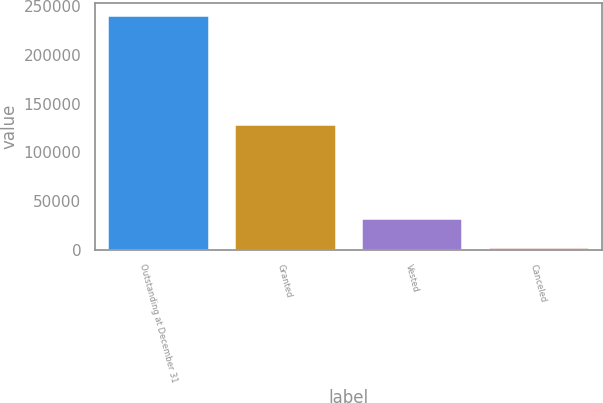<chart> <loc_0><loc_0><loc_500><loc_500><bar_chart><fcel>Outstanding at December 31<fcel>Granted<fcel>Vested<fcel>Canceled<nl><fcel>241284<fcel>129000<fcel>32400<fcel>2500<nl></chart> 